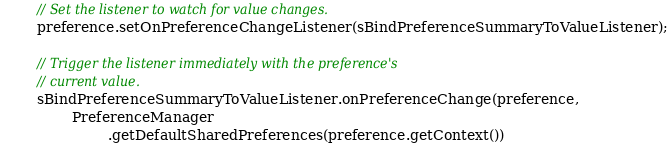Convert code to text. <code><loc_0><loc_0><loc_500><loc_500><_Java_>        // Set the listener to watch for value changes.
        preference.setOnPreferenceChangeListener(sBindPreferenceSummaryToValueListener);

        // Trigger the listener immediately with the preference's
        // current value.
        sBindPreferenceSummaryToValueListener.onPreferenceChange(preference,
                PreferenceManager
                        .getDefaultSharedPreferences(preference.getContext())</code> 